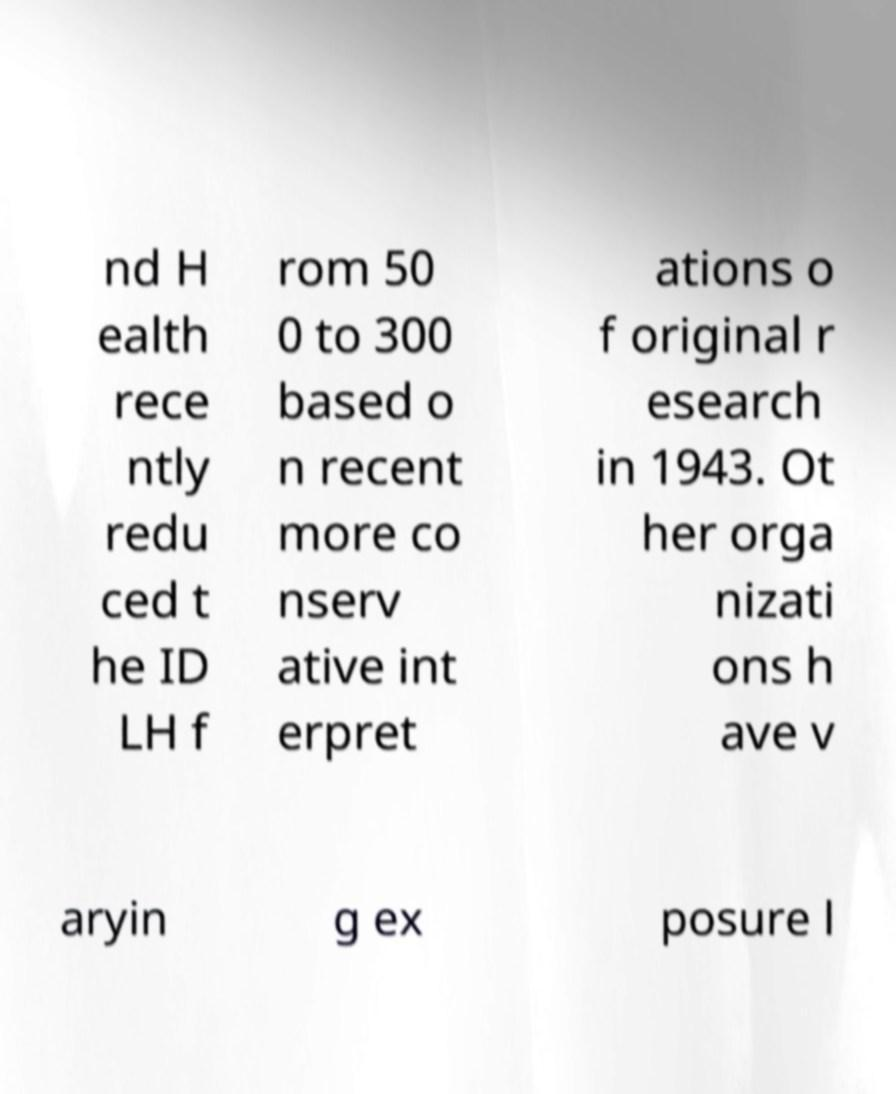Can you read and provide the text displayed in the image?This photo seems to have some interesting text. Can you extract and type it out for me? nd H ealth rece ntly redu ced t he ID LH f rom 50 0 to 300 based o n recent more co nserv ative int erpret ations o f original r esearch in 1943. Ot her orga nizati ons h ave v aryin g ex posure l 